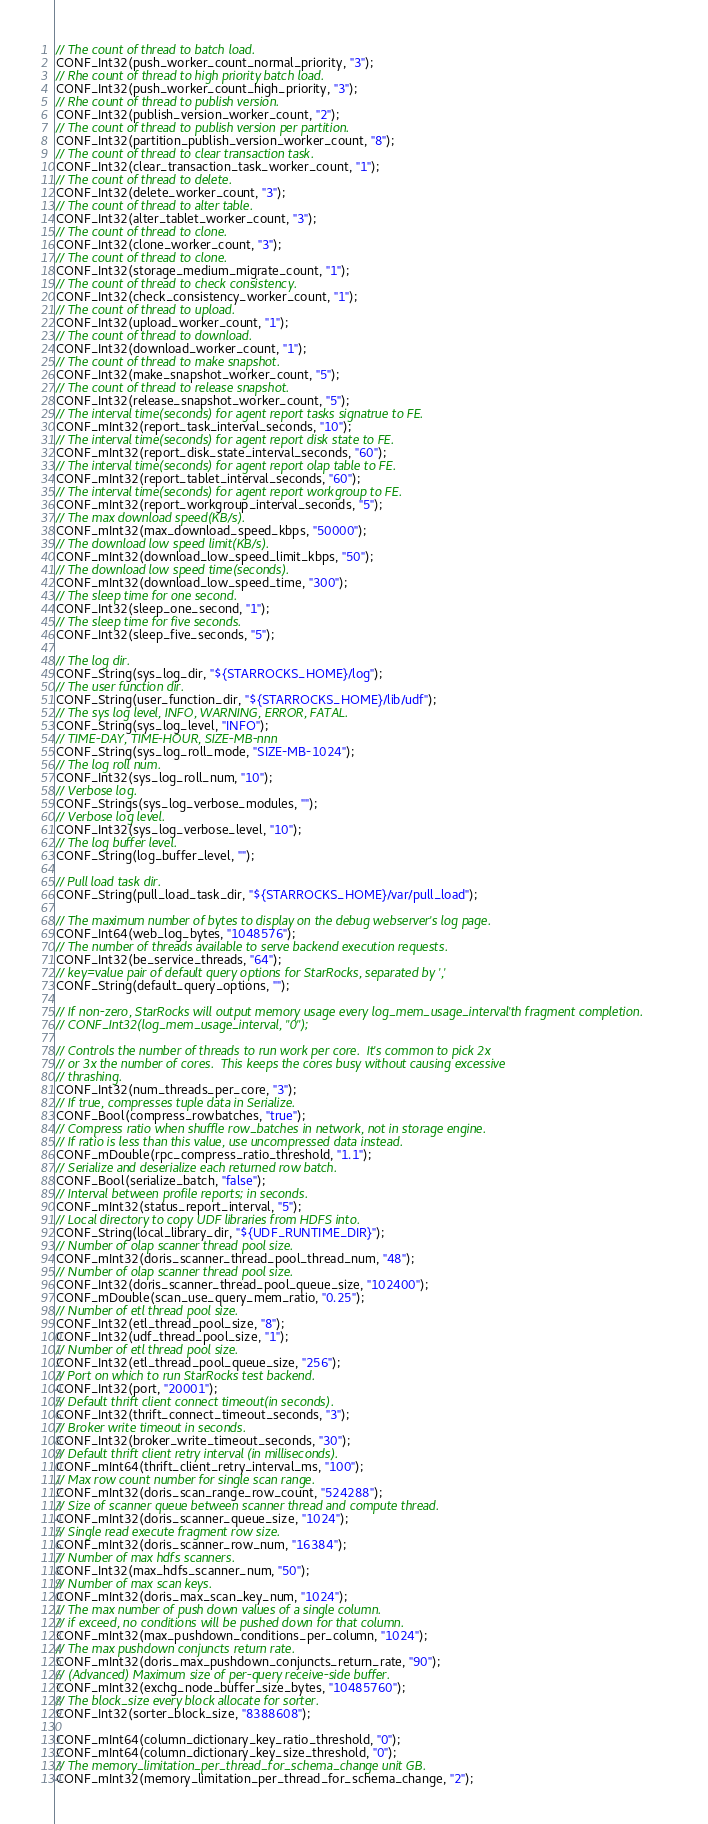<code> <loc_0><loc_0><loc_500><loc_500><_C_>// The count of thread to batch load.
CONF_Int32(push_worker_count_normal_priority, "3");
// Rhe count of thread to high priority batch load.
CONF_Int32(push_worker_count_high_priority, "3");
// Rhe count of thread to publish version.
CONF_Int32(publish_version_worker_count, "2");
// The count of thread to publish version per partition.
CONF_Int32(partition_publish_version_worker_count, "8");
// The count of thread to clear transaction task.
CONF_Int32(clear_transaction_task_worker_count, "1");
// The count of thread to delete.
CONF_Int32(delete_worker_count, "3");
// The count of thread to alter table.
CONF_Int32(alter_tablet_worker_count, "3");
// The count of thread to clone.
CONF_Int32(clone_worker_count, "3");
// The count of thread to clone.
CONF_Int32(storage_medium_migrate_count, "1");
// The count of thread to check consistency.
CONF_Int32(check_consistency_worker_count, "1");
// The count of thread to upload.
CONF_Int32(upload_worker_count, "1");
// The count of thread to download.
CONF_Int32(download_worker_count, "1");
// The count of thread to make snapshot.
CONF_Int32(make_snapshot_worker_count, "5");
// The count of thread to release snapshot.
CONF_Int32(release_snapshot_worker_count, "5");
// The interval time(seconds) for agent report tasks signatrue to FE.
CONF_mInt32(report_task_interval_seconds, "10");
// The interval time(seconds) for agent report disk state to FE.
CONF_mInt32(report_disk_state_interval_seconds, "60");
// The interval time(seconds) for agent report olap table to FE.
CONF_mInt32(report_tablet_interval_seconds, "60");
// The interval time(seconds) for agent report workgroup to FE.
CONF_mInt32(report_workgroup_interval_seconds, "5");
// The max download speed(KB/s).
CONF_mInt32(max_download_speed_kbps, "50000");
// The download low speed limit(KB/s).
CONF_mInt32(download_low_speed_limit_kbps, "50");
// The download low speed time(seconds).
CONF_mInt32(download_low_speed_time, "300");
// The sleep time for one second.
CONF_Int32(sleep_one_second, "1");
// The sleep time for five seconds.
CONF_Int32(sleep_five_seconds, "5");

// The log dir.
CONF_String(sys_log_dir, "${STARROCKS_HOME}/log");
// The user function dir.
CONF_String(user_function_dir, "${STARROCKS_HOME}/lib/udf");
// The sys log level, INFO, WARNING, ERROR, FATAL.
CONF_String(sys_log_level, "INFO");
// TIME-DAY, TIME-HOUR, SIZE-MB-nnn
CONF_String(sys_log_roll_mode, "SIZE-MB-1024");
// The log roll num.
CONF_Int32(sys_log_roll_num, "10");
// Verbose log.
CONF_Strings(sys_log_verbose_modules, "");
// Verbose log level.
CONF_Int32(sys_log_verbose_level, "10");
// The log buffer level.
CONF_String(log_buffer_level, "");

// Pull load task dir.
CONF_String(pull_load_task_dir, "${STARROCKS_HOME}/var/pull_load");

// The maximum number of bytes to display on the debug webserver's log page.
CONF_Int64(web_log_bytes, "1048576");
// The number of threads available to serve backend execution requests.
CONF_Int32(be_service_threads, "64");
// key=value pair of default query options for StarRocks, separated by ','
CONF_String(default_query_options, "");

// If non-zero, StarRocks will output memory usage every log_mem_usage_interval'th fragment completion.
// CONF_Int32(log_mem_usage_interval, "0");

// Controls the number of threads to run work per core.  It's common to pick 2x
// or 3x the number of cores.  This keeps the cores busy without causing excessive
// thrashing.
CONF_Int32(num_threads_per_core, "3");
// If true, compresses tuple data in Serialize.
CONF_Bool(compress_rowbatches, "true");
// Compress ratio when shuffle row_batches in network, not in storage engine.
// If ratio is less than this value, use uncompressed data instead.
CONF_mDouble(rpc_compress_ratio_threshold, "1.1");
// Serialize and deserialize each returned row batch.
CONF_Bool(serialize_batch, "false");
// Interval between profile reports; in seconds.
CONF_mInt32(status_report_interval, "5");
// Local directory to copy UDF libraries from HDFS into.
CONF_String(local_library_dir, "${UDF_RUNTIME_DIR}");
// Number of olap scanner thread pool size.
CONF_mInt32(doris_scanner_thread_pool_thread_num, "48");
// Number of olap scanner thread pool size.
CONF_Int32(doris_scanner_thread_pool_queue_size, "102400");
CONF_mDouble(scan_use_query_mem_ratio, "0.25");
// Number of etl thread pool size.
CONF_Int32(etl_thread_pool_size, "8");
CONF_Int32(udf_thread_pool_size, "1");
// Number of etl thread pool size.
CONF_Int32(etl_thread_pool_queue_size, "256");
// Port on which to run StarRocks test backend.
CONF_Int32(port, "20001");
// Default thrift client connect timeout(in seconds).
CONF_Int32(thrift_connect_timeout_seconds, "3");
// Broker write timeout in seconds.
CONF_Int32(broker_write_timeout_seconds, "30");
// Default thrift client retry interval (in milliseconds).
CONF_mInt64(thrift_client_retry_interval_ms, "100");
// Max row count number for single scan range.
CONF_mInt32(doris_scan_range_row_count, "524288");
// Size of scanner queue between scanner thread and compute thread.
CONF_mInt32(doris_scanner_queue_size, "1024");
// Single read execute fragment row size.
CONF_mInt32(doris_scanner_row_num, "16384");
// Number of max hdfs scanners.
CONF_Int32(max_hdfs_scanner_num, "50");
// Number of max scan keys.
CONF_mInt32(doris_max_scan_key_num, "1024");
// The max number of push down values of a single column.
// if exceed, no conditions will be pushed down for that column.
CONF_mInt32(max_pushdown_conditions_per_column, "1024");
// The max pushdown conjuncts return rate.
CONF_mInt32(doris_max_pushdown_conjuncts_return_rate, "90");
// (Advanced) Maximum size of per-query receive-side buffer.
CONF_mInt32(exchg_node_buffer_size_bytes, "10485760");
// The block_size every block allocate for sorter.
CONF_Int32(sorter_block_size, "8388608");

CONF_mInt64(column_dictionary_key_ratio_threshold, "0");
CONF_mInt64(column_dictionary_key_size_threshold, "0");
// The memory_limitation_per_thread_for_schema_change unit GB.
CONF_mInt32(memory_limitation_per_thread_for_schema_change, "2");
</code> 